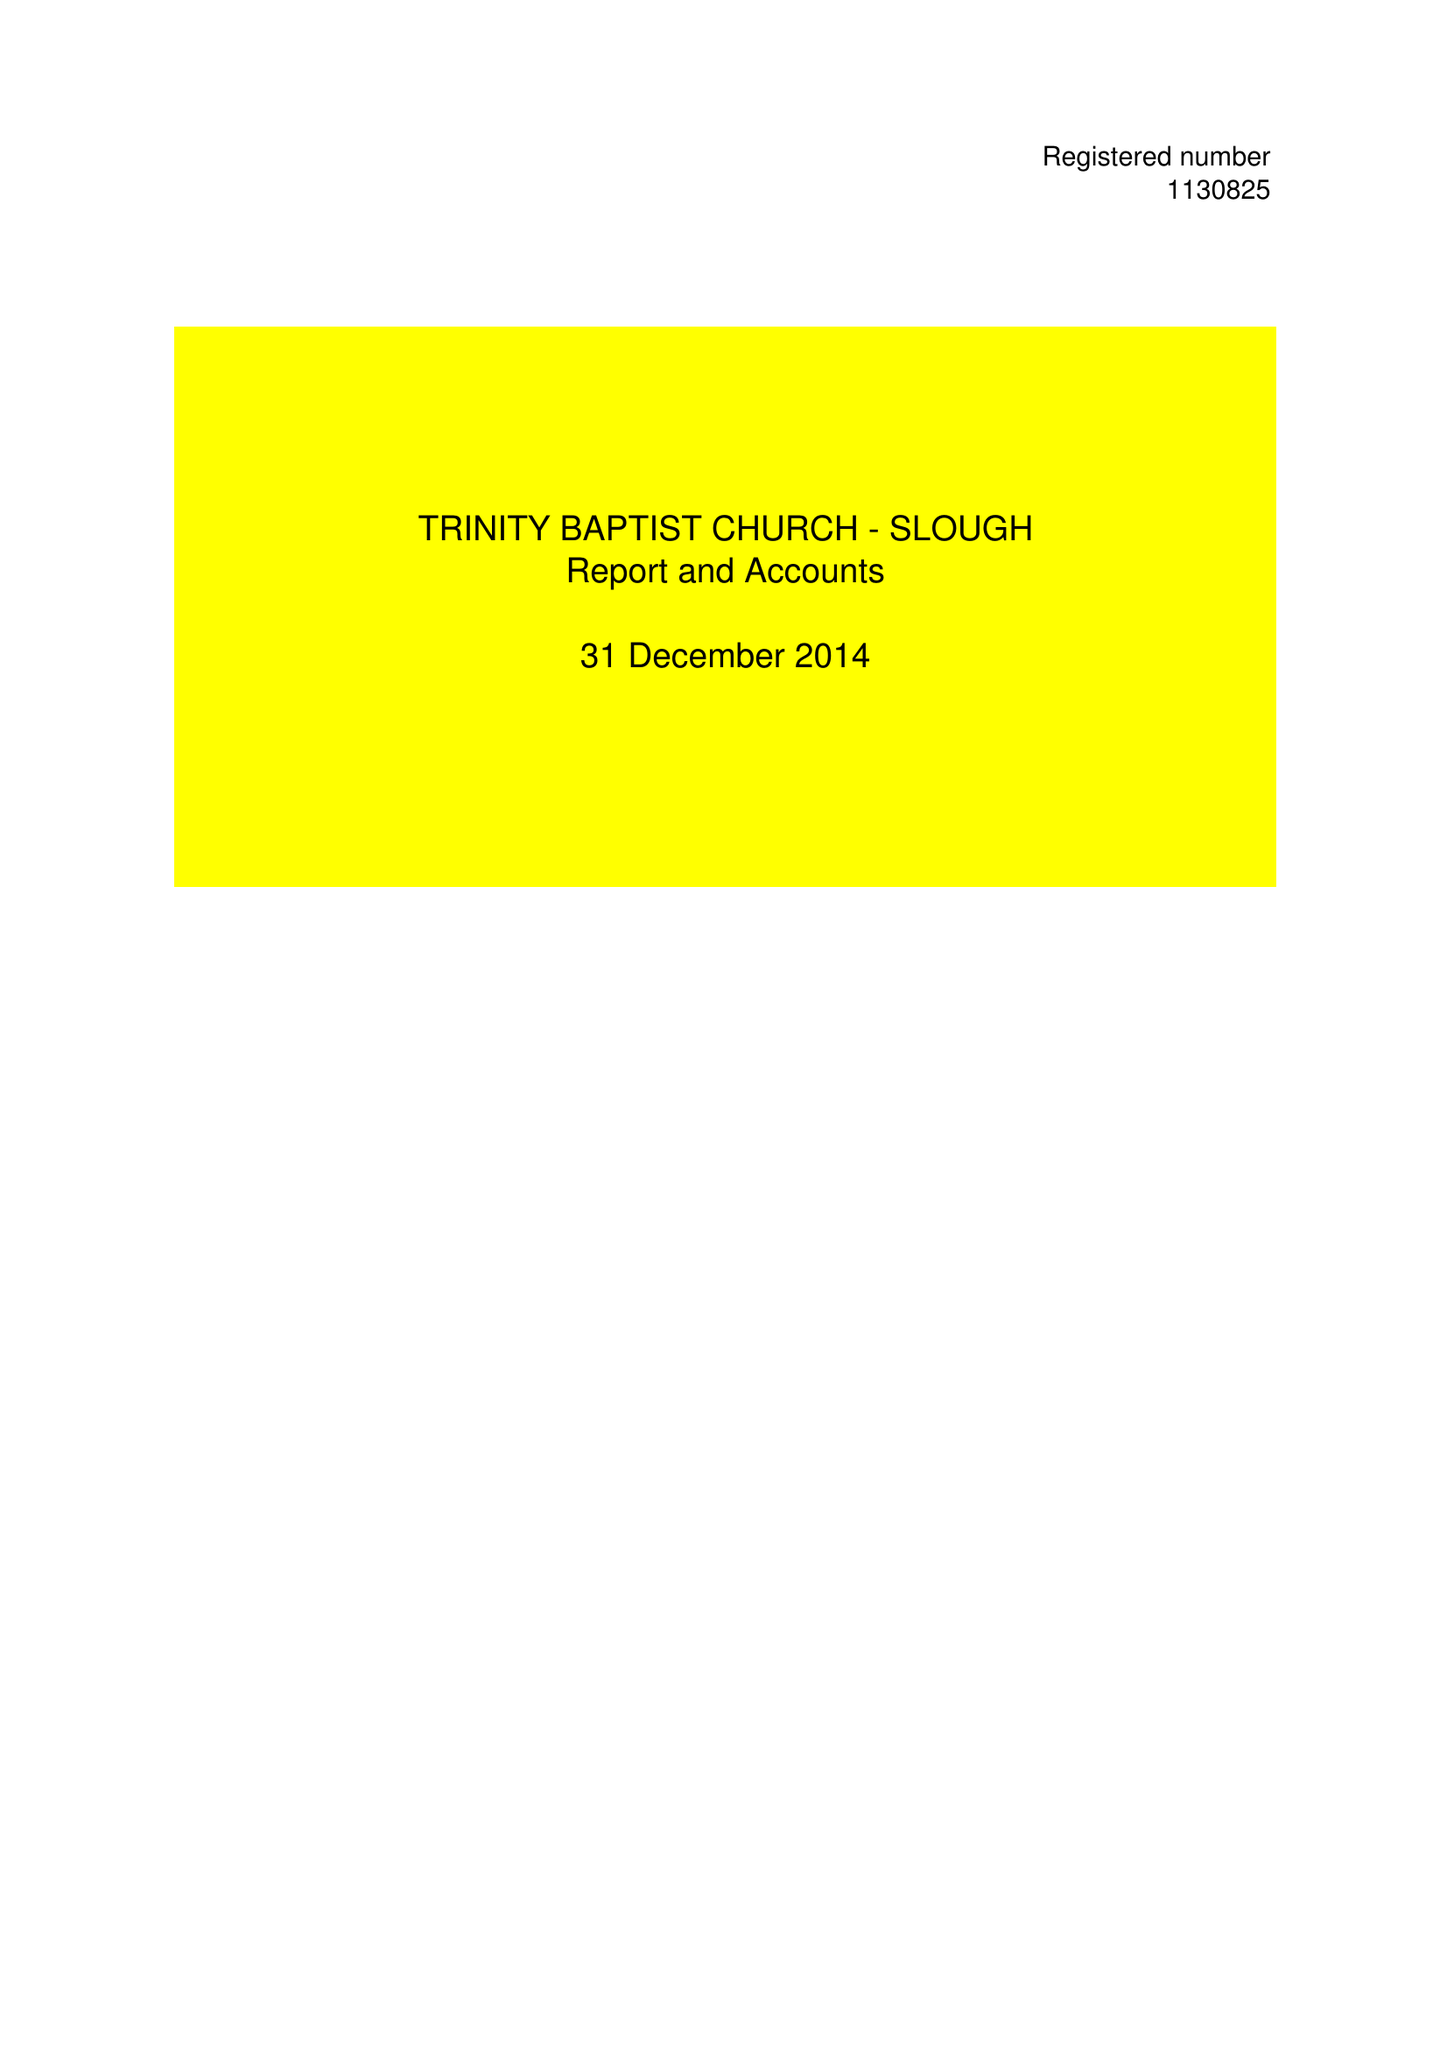What is the value for the income_annually_in_british_pounds?
Answer the question using a single word or phrase. 72917.00 